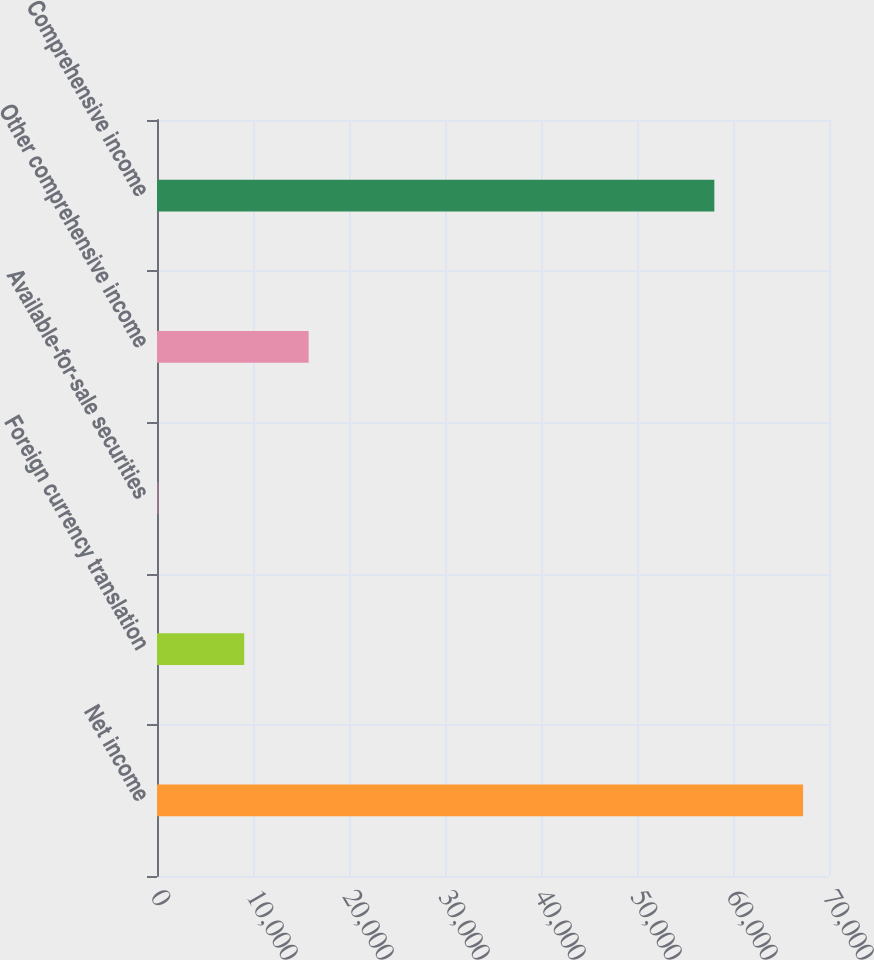<chart> <loc_0><loc_0><loc_500><loc_500><bar_chart><fcel>Net income<fcel>Foreign currency translation<fcel>Available-for-sale securities<fcel>Other comprehensive income<fcel>Comprehensive income<nl><fcel>67303<fcel>9086<fcel>169<fcel>15799.4<fcel>58057<nl></chart> 